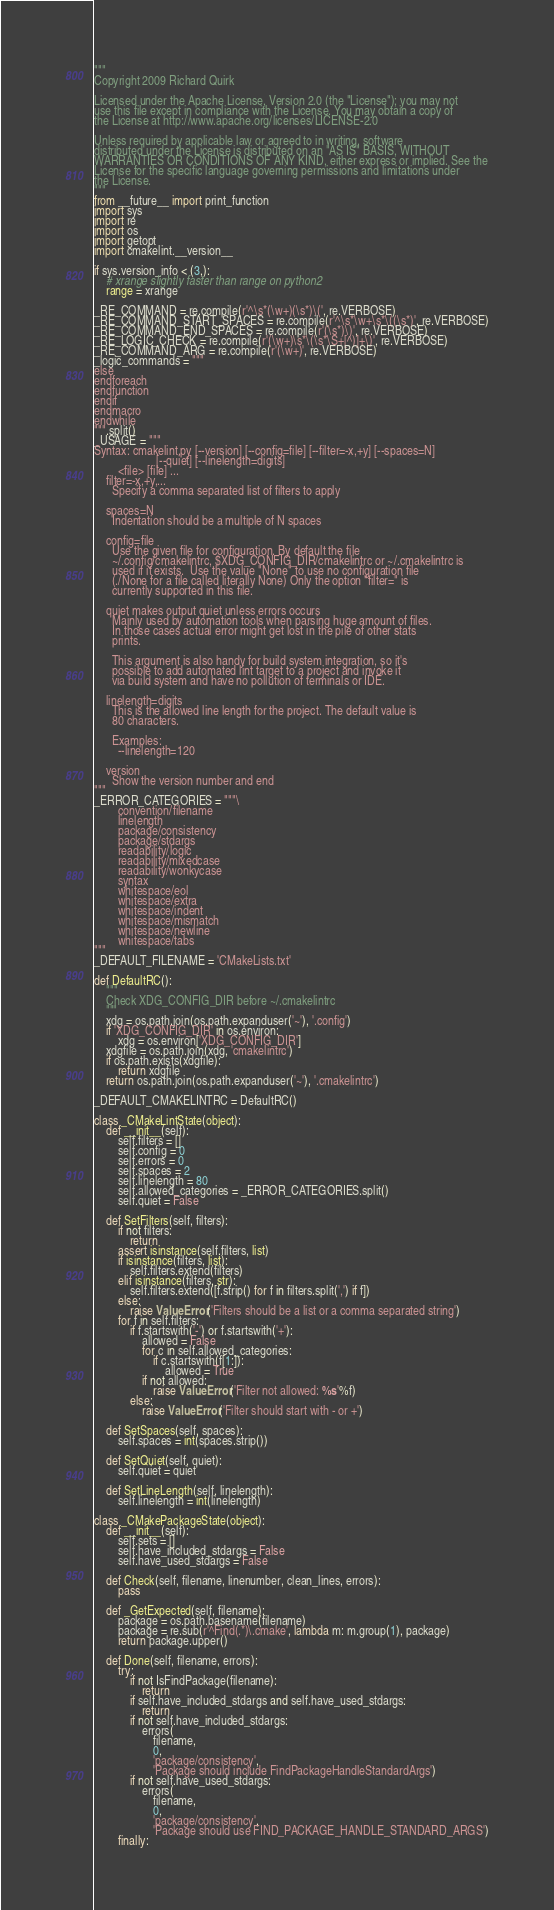Convert code to text. <code><loc_0><loc_0><loc_500><loc_500><_Python_>"""
Copyright 2009 Richard Quirk

Licensed under the Apache License, Version 2.0 (the "License"); you may not
use this file except in compliance with the License. You may obtain a copy of
the License at http://www.apache.org/licenses/LICENSE-2.0

Unless required by applicable law or agreed to in writing, software
distributed under the License is distributed on an "AS IS" BASIS, WITHOUT
WARRANTIES OR CONDITIONS OF ANY KIND, either express or implied. See the
License for the specific language governing permissions and limitations under
the License.
"""
from __future__ import print_function
import sys
import re
import os
import getopt
import cmakelint.__version__

if sys.version_info < (3,):
    # xrange slightly faster than range on python2
    range = xrange

_RE_COMMAND = re.compile(r'^\s*(\w+)(\s*)\(', re.VERBOSE)
_RE_COMMAND_START_SPACES = re.compile(r'^\s*\w+\s*\((\s*)', re.VERBOSE)
_RE_COMMAND_END_SPACES = re.compile(r'(\s*)\)', re.VERBOSE)
_RE_LOGIC_CHECK = re.compile(r'(\w+)\s*\(\s*\S+[^)]+\)', re.VERBOSE)
_RE_COMMAND_ARG = re.compile(r'(\w+)', re.VERBOSE)
_logic_commands = """
else
endforeach
endfunction
endif
endmacro
endwhile
""".split()
_USAGE = """
Syntax: cmakelint.py [--version] [--config=file] [--filter=-x,+y] [--spaces=N]
                     [--quiet] [--linelength=digits]
        <file> [file] ...
    filter=-x,+y,...
      Specify a comma separated list of filters to apply

    spaces=N
      Indentation should be a multiple of N spaces

    config=file
      Use the given file for configuration. By default the file
      ~/.config/cmakelintrc, $XDG_CONFIG_DIR/cmakelintrc or ~/.cmakelintrc is
      used if it exists.  Use the value "None" to use no configuration file
      (./None for a file called literally None) Only the option "filter=" is
      currently supported in this file.

    quiet makes output quiet unless errors occurs
      Mainly used by automation tools when parsing huge amount of files.
      In those cases actual error might get lost in the pile of other stats
      prints.

      This argument is also handy for build system integration, so it's
      possible to add automated lint target to a project and invoke it
      via build system and have no pollution of terminals or IDE.

    linelength=digits
      This is the allowed line length for the project. The default value is
      80 characters.

      Examples:
        --linelength=120

    version
      Show the version number and end
"""
_ERROR_CATEGORIES = """\
        convention/filename
        linelength
        package/consistency
        package/stdargs
        readability/logic
        readability/mixedcase
        readability/wonkycase
        syntax
        whitespace/eol
        whitespace/extra
        whitespace/indent
        whitespace/mismatch
        whitespace/newline
        whitespace/tabs
"""
_DEFAULT_FILENAME = 'CMakeLists.txt'

def DefaultRC():
    """
    Check XDG_CONFIG_DIR before ~/.cmakelintrc
    """
    xdg = os.path.join(os.path.expanduser('~'), '.config')
    if 'XDG_CONFIG_DIR' in os.environ:
        xdg = os.environ['XDG_CONFIG_DIR']
    xdgfile = os.path.join(xdg, 'cmakelintrc')
    if os.path.exists(xdgfile):
        return xdgfile
    return os.path.join(os.path.expanduser('~'), '.cmakelintrc')

_DEFAULT_CMAKELINTRC = DefaultRC()

class _CMakeLintState(object):
    def __init__(self):
        self.filters = []
        self.config = 0
        self.errors = 0
        self.spaces = 2
        self.linelength = 80
        self.allowed_categories = _ERROR_CATEGORIES.split()
        self.quiet = False

    def SetFilters(self, filters):
        if not filters:
            return
        assert isinstance(self.filters, list)
        if isinstance(filters, list):
            self.filters.extend(filters)
        elif isinstance(filters, str):
            self.filters.extend([f.strip() for f in filters.split(',') if f])
        else:
            raise ValueError('Filters should be a list or a comma separated string')
        for f in self.filters:
            if f.startswith('-') or f.startswith('+'):
                allowed = False
                for c in self.allowed_categories:
                    if c.startswith(f[1:]):
                        allowed = True
                if not allowed:
                    raise ValueError('Filter not allowed: %s'%f)
            else:
                raise ValueError('Filter should start with - or +')

    def SetSpaces(self, spaces):
        self.spaces = int(spaces.strip())

    def SetQuiet(self, quiet):
        self.quiet = quiet

    def SetLineLength(self, linelength):
        self.linelength = int(linelength)

class _CMakePackageState(object):
    def __init__(self):
        self.sets = []
        self.have_included_stdargs = False
        self.have_used_stdargs = False

    def Check(self, filename, linenumber, clean_lines, errors):
        pass

    def _GetExpected(self, filename):
        package = os.path.basename(filename)
        package = re.sub(r'^Find(.*)\.cmake', lambda m: m.group(1), package)
        return package.upper()

    def Done(self, filename, errors):
        try:
            if not IsFindPackage(filename):
                return
            if self.have_included_stdargs and self.have_used_stdargs:
                return
            if not self.have_included_stdargs:
                errors(
                    filename,
                    0,
                    'package/consistency',
                    'Package should include FindPackageHandleStandardArgs')
            if not self.have_used_stdargs:
                errors(
                    filename,
                    0,
                    'package/consistency',
                    'Package should use FIND_PACKAGE_HANDLE_STANDARD_ARGS')
        finally:</code> 